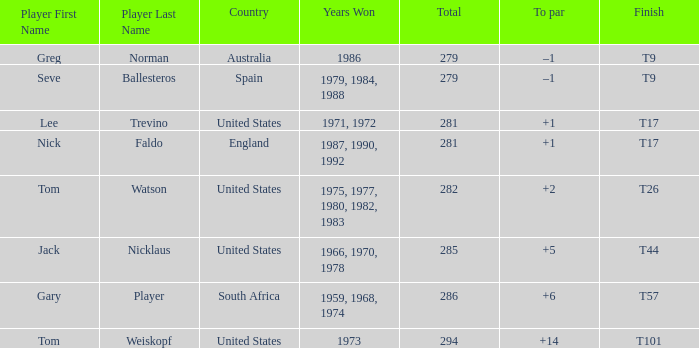Who has the highest total and a to par of +14? 294.0. 